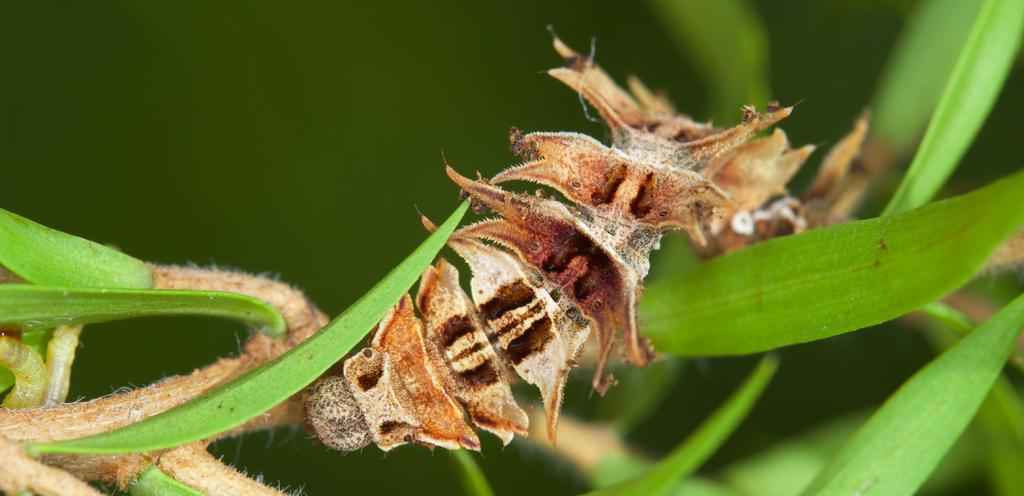What type of creature can be seen in the image? There is an insect in the image. What type of vegetation is present in the image? There are green leaves in the image. How would you describe the quality of the image's background? The image is blurry in the background. How many cords are visible in the image? There are no cords present in the image. What type of adjustment can be made to the insect in the image? There is no adjustment that can be made to the insect in the image, as it is a static photograph. 